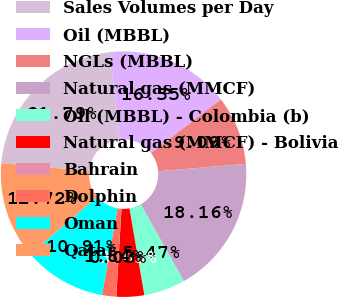<chart> <loc_0><loc_0><loc_500><loc_500><pie_chart><fcel>Sales Volumes per Day<fcel>Oil (MBBL)<fcel>NGLs (MBBL)<fcel>Natural gas (MMCF)<fcel>Oil (MBBL) - Colombia (b)<fcel>Natural gas (MMCF) - Bolivia<fcel>Bahrain<fcel>Dolphin<fcel>Oman<fcel>Qatar<nl><fcel>21.79%<fcel>16.35%<fcel>9.09%<fcel>18.16%<fcel>5.47%<fcel>3.65%<fcel>0.03%<fcel>1.84%<fcel>10.91%<fcel>12.72%<nl></chart> 